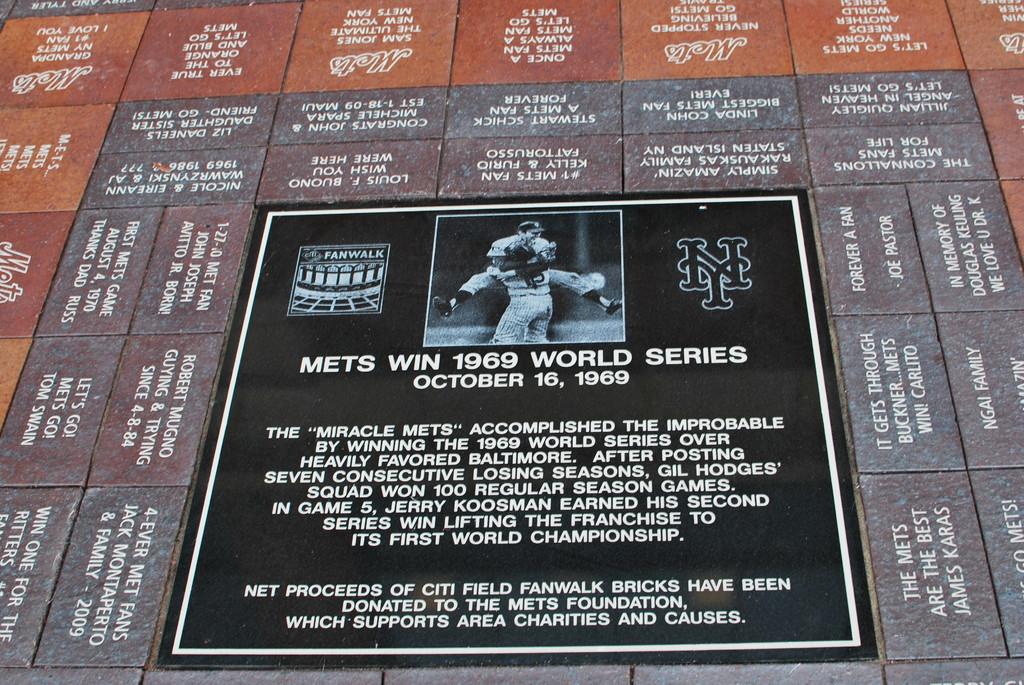What year is displayed?
Offer a very short reply. 1969. 